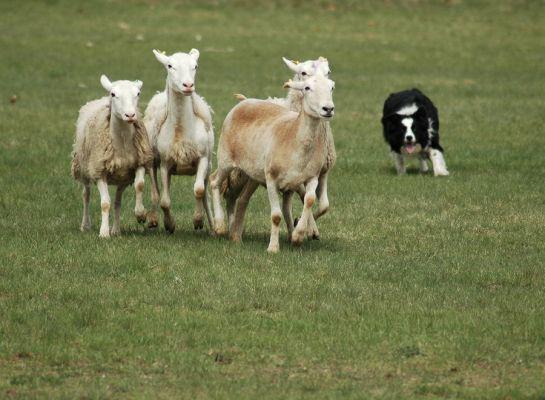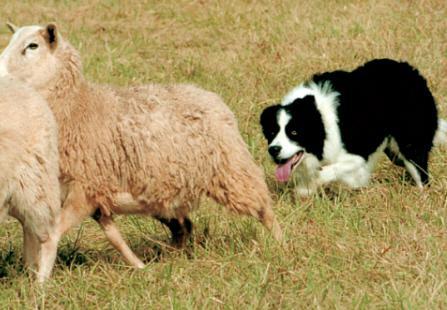The first image is the image on the left, the second image is the image on the right. Given the left and right images, does the statement "The dog in the image on the left is rounding up cattle." hold true? Answer yes or no. No. The first image is the image on the left, the second image is the image on the right. Examine the images to the left and right. Is the description "There are three sheeps and one dog in one of the images." accurate? Answer yes or no. Yes. 